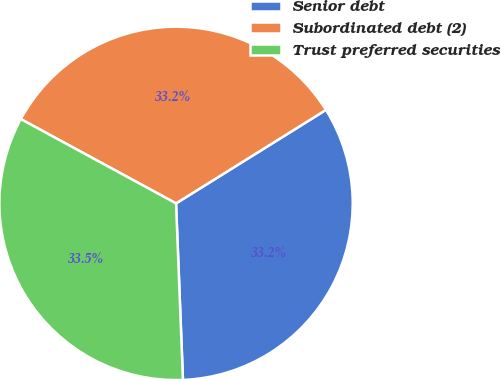Convert chart to OTSL. <chart><loc_0><loc_0><loc_500><loc_500><pie_chart><fcel>Senior debt<fcel>Subordinated debt (2)<fcel>Trust preferred securities<nl><fcel>33.25%<fcel>33.21%<fcel>33.54%<nl></chart> 